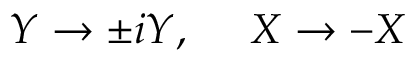Convert formula to latex. <formula><loc_0><loc_0><loc_500><loc_500>Y \rightarrow \pm i Y , \quad X \rightarrow - X</formula> 